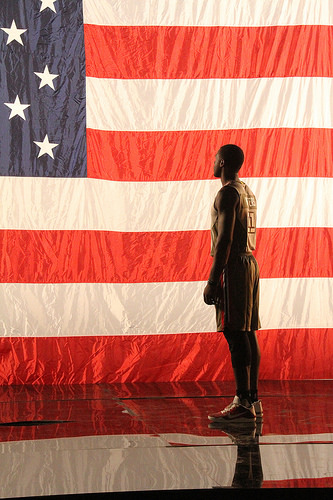<image>
Is there a man on the flag? No. The man is not positioned on the flag. They may be near each other, but the man is not supported by or resting on top of the flag. 